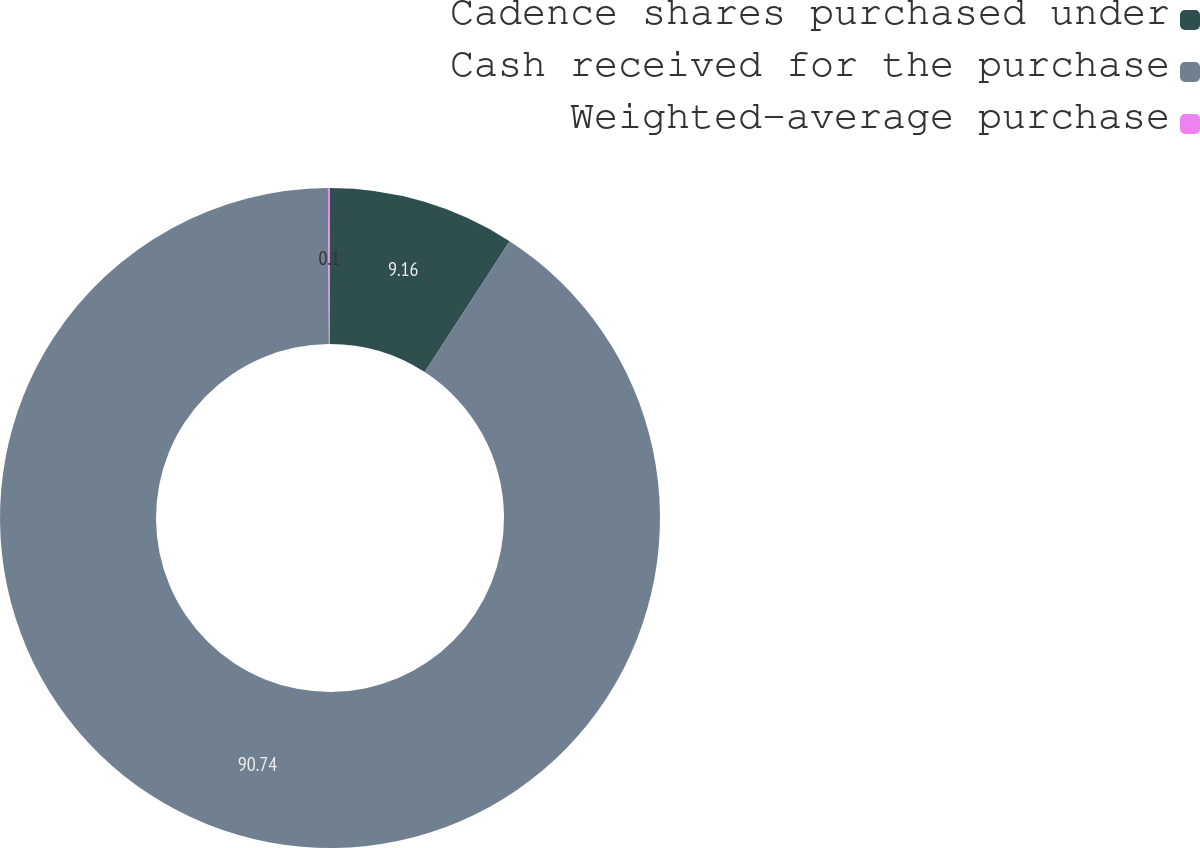<chart> <loc_0><loc_0><loc_500><loc_500><pie_chart><fcel>Cadence shares purchased under<fcel>Cash received for the purchase<fcel>Weighted-average purchase<nl><fcel>9.16%<fcel>90.73%<fcel>0.1%<nl></chart> 